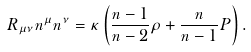<formula> <loc_0><loc_0><loc_500><loc_500>R _ { \mu \nu } n ^ { \mu } n ^ { \nu } = \kappa \left ( { \frac { n - 1 } { n - 2 } } \rho + { \frac { n } { n - 1 } } P \right ) .</formula> 